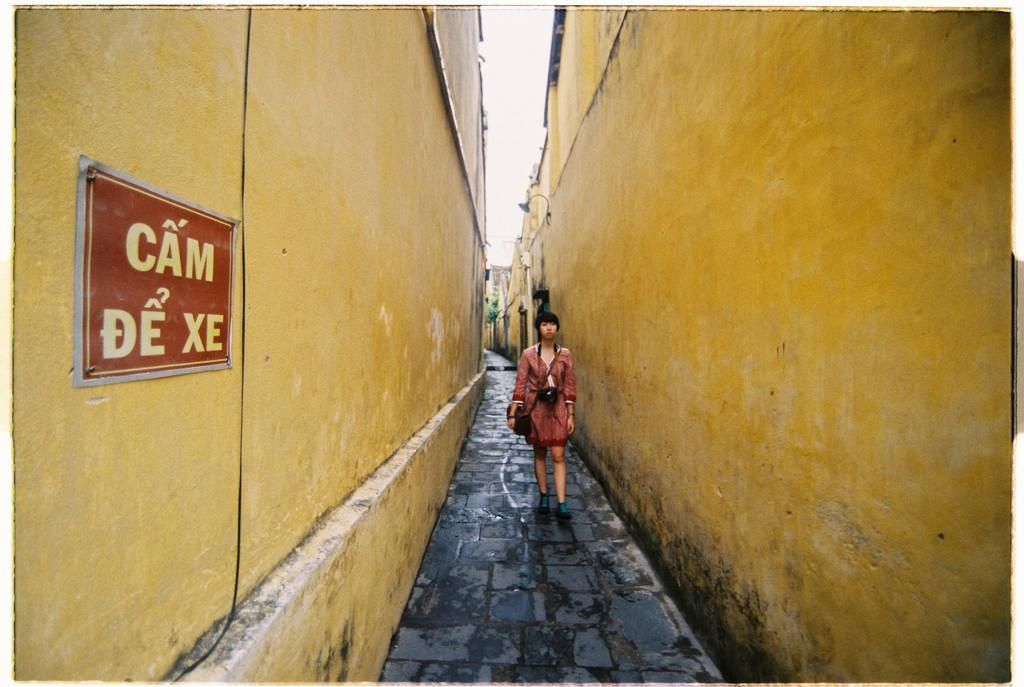Provide a one-sentence caption for the provided image. A woman walking down a long ally way with yellow walls and a red sign that reads cam de xe. 